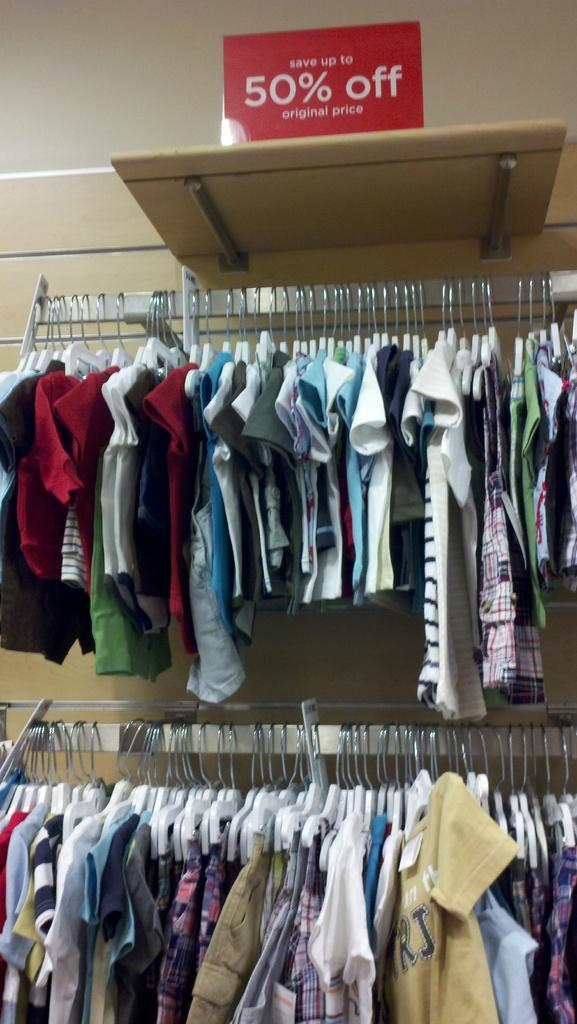Provide a one-sentence caption for the provided image. Two racks of a variety of baby and children's clothes which are 50% percent off. 